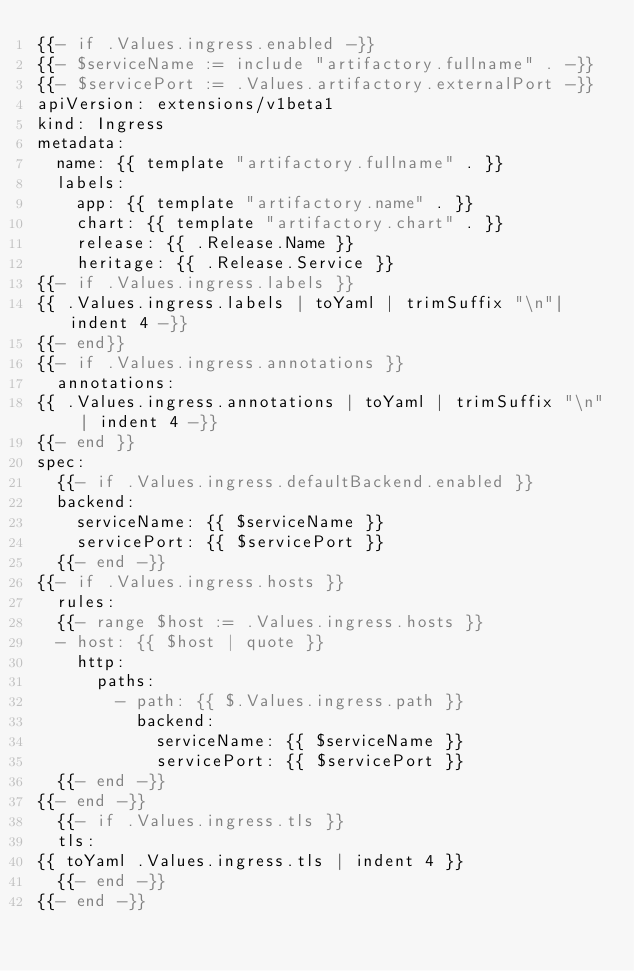<code> <loc_0><loc_0><loc_500><loc_500><_YAML_>{{- if .Values.ingress.enabled -}}
{{- $serviceName := include "artifactory.fullname" . -}}
{{- $servicePort := .Values.artifactory.externalPort -}}
apiVersion: extensions/v1beta1
kind: Ingress
metadata:
  name: {{ template "artifactory.fullname" . }}
  labels:
    app: {{ template "artifactory.name" . }}
    chart: {{ template "artifactory.chart" . }}
    release: {{ .Release.Name }}
    heritage: {{ .Release.Service }}
{{- if .Values.ingress.labels }}
{{ .Values.ingress.labels | toYaml | trimSuffix "\n"| indent 4 -}}
{{- end}}
{{- if .Values.ingress.annotations }}
  annotations:
{{ .Values.ingress.annotations | toYaml | trimSuffix "\n" | indent 4 -}}
{{- end }}
spec:
  {{- if .Values.ingress.defaultBackend.enabled }}
  backend:
    serviceName: {{ $serviceName }}
    servicePort: {{ $servicePort }}
  {{- end -}}
{{- if .Values.ingress.hosts }}
  rules:
  {{- range $host := .Values.ingress.hosts }}
  - host: {{ $host | quote }}
    http:
      paths:
        - path: {{ $.Values.ingress.path }}
          backend:
            serviceName: {{ $serviceName }}
            servicePort: {{ $servicePort }}
  {{- end -}}
{{- end -}}
  {{- if .Values.ingress.tls }}
  tls:
{{ toYaml .Values.ingress.tls | indent 4 }}
  {{- end -}}
{{- end -}}
</code> 